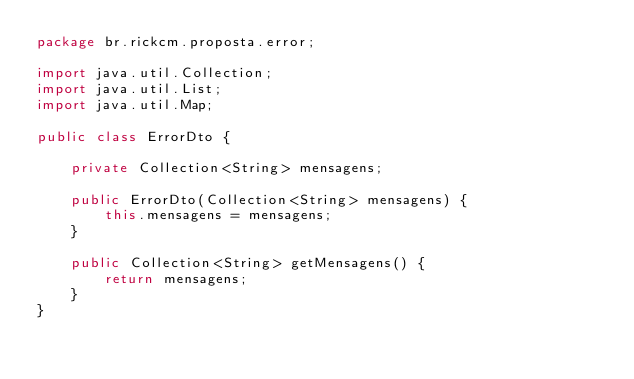<code> <loc_0><loc_0><loc_500><loc_500><_Java_>package br.rickcm.proposta.error;

import java.util.Collection;
import java.util.List;
import java.util.Map;

public class ErrorDto {

    private Collection<String> mensagens;

    public ErrorDto(Collection<String> mensagens) {
        this.mensagens = mensagens;
    }

    public Collection<String> getMensagens() {
        return mensagens;
    }
}
</code> 